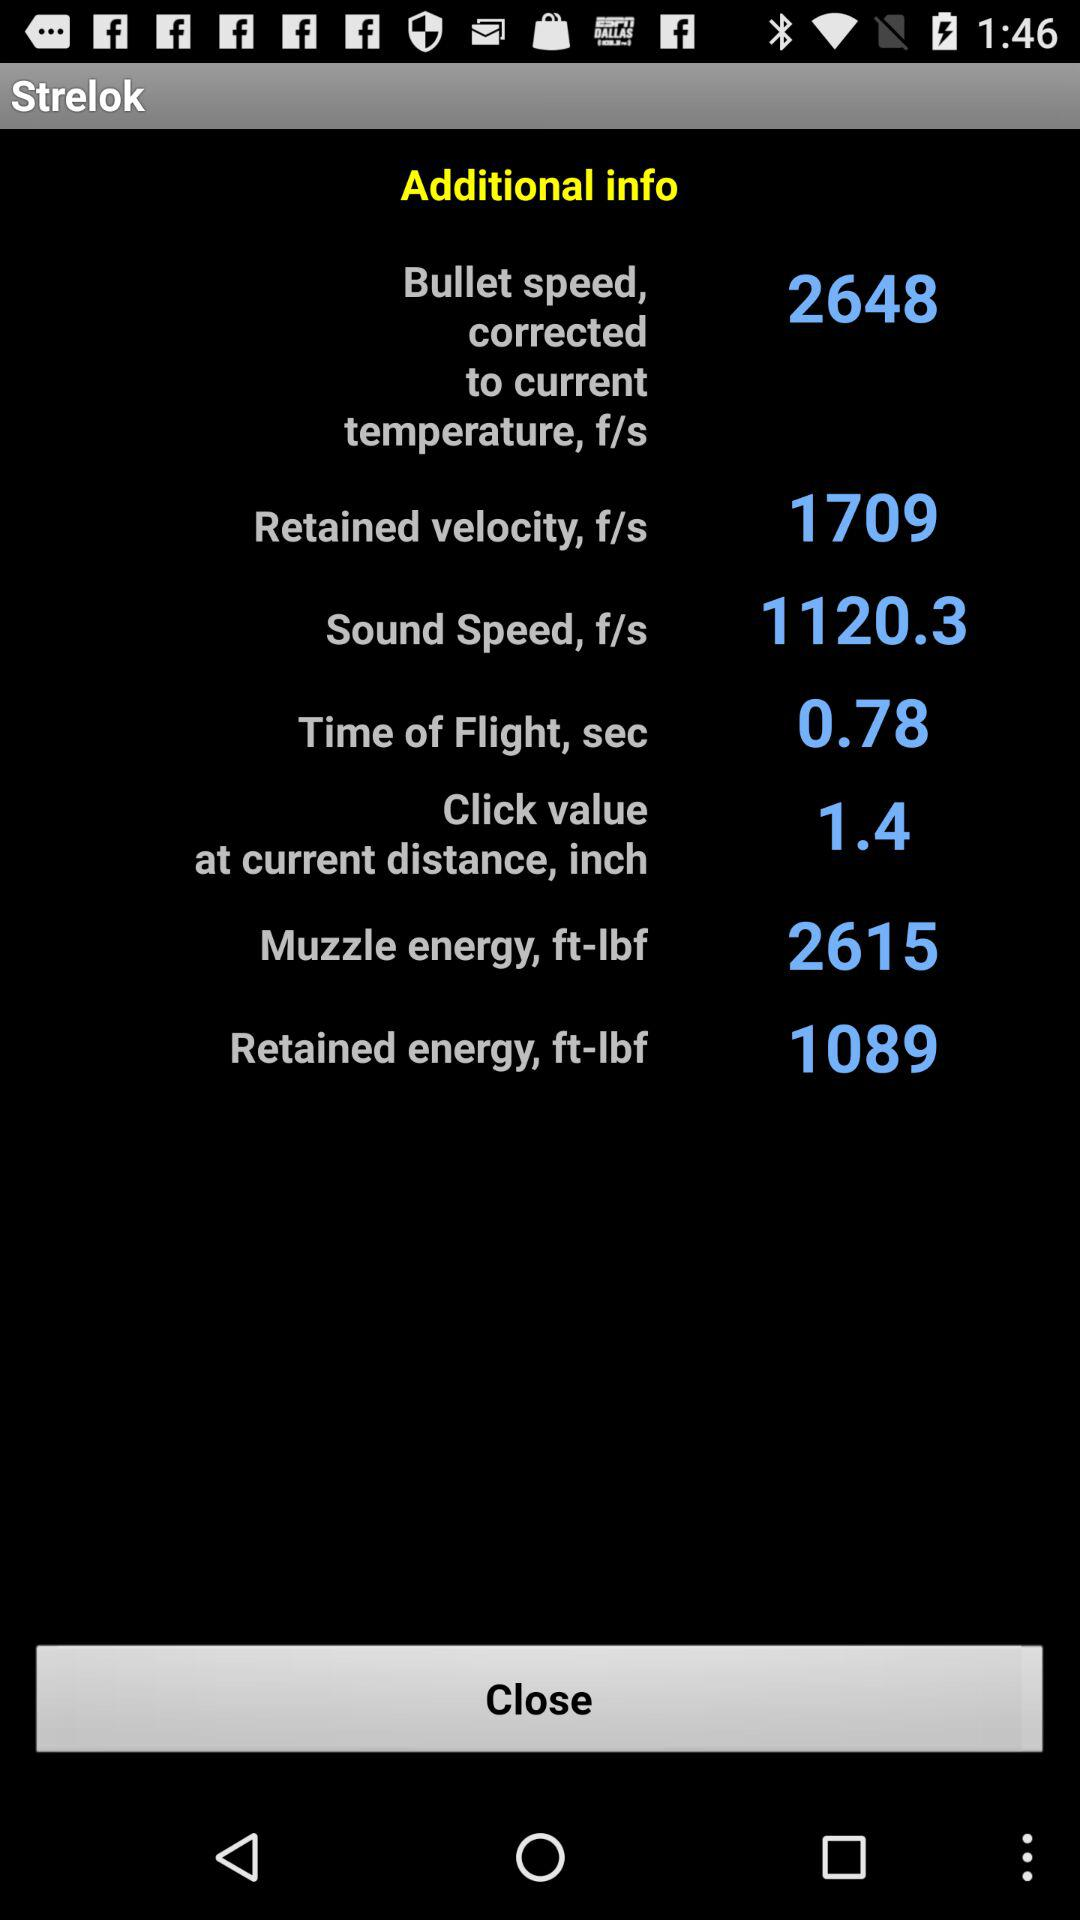What is the sound speed? The sound speed is 1120.3. 